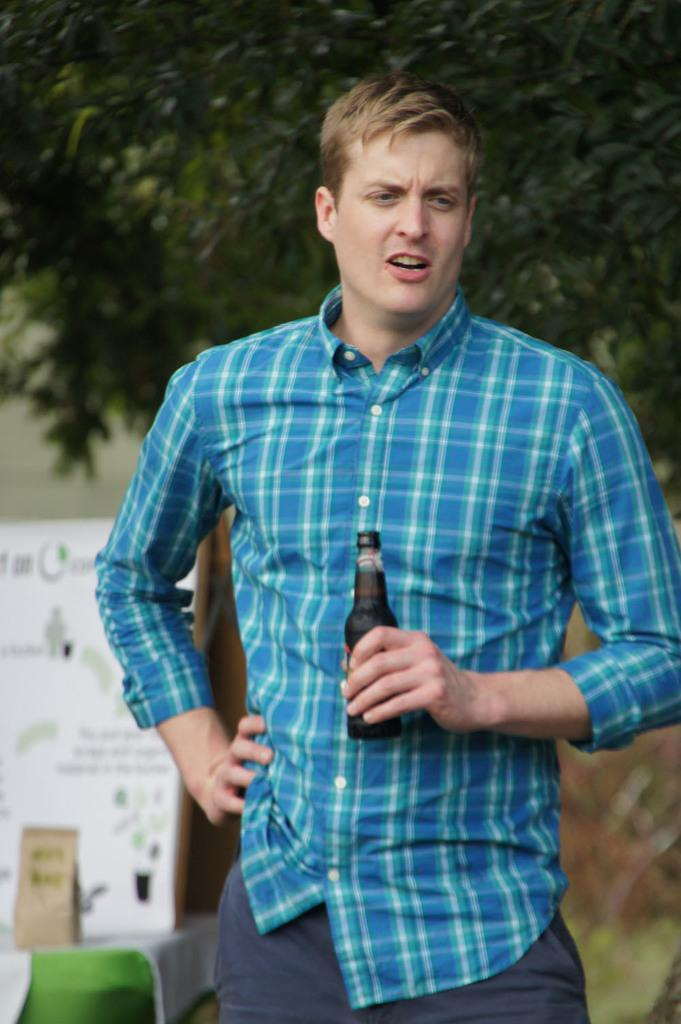Who is present in the image? There is a person in the image. What is the person wearing? The person is wearing a sky blue color shirt. What is the person holding in the image? The person is holding a bottle. What can be seen in the background of the image? There is a tree, a banner, and a wall in the background of the image. What religion does the person in the image practice? There is no information about the person's religion in the image. How much does the person in the image weigh? There is no information about the person's weight in the image. 